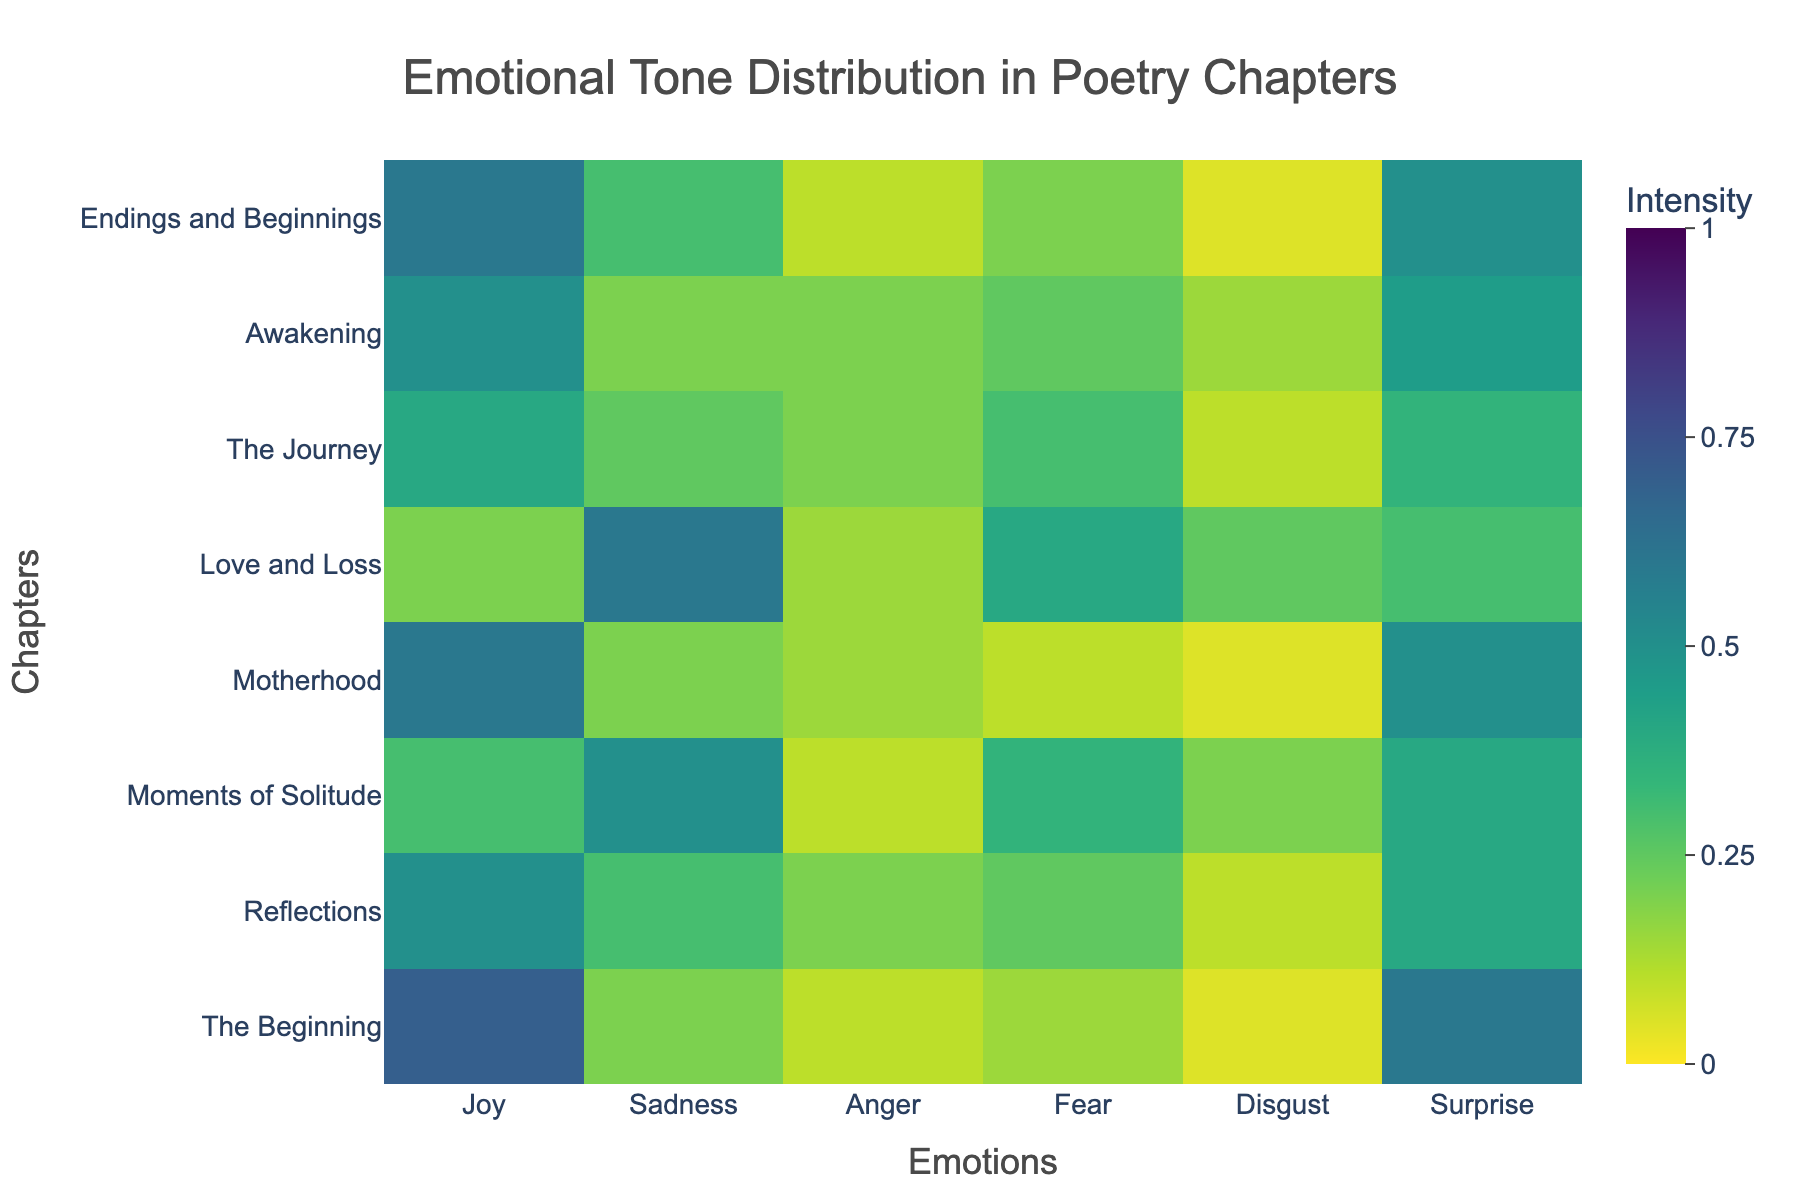What is the title of the figure? The title of a Heatmap is displayed at the top center of the figure. It provides a summary of what the graph represents. From the given information, it is "Emotional Tone Distribution in Poetry Chapters"
Answer: Emotional Tone Distribution in Poetry Chapters Which chapter has the highest intensity of joy? To answer this, look at the row corresponding to each chapter and identify the one with the highest value in the "Joy" column. "The Beginning" and "Motherhood" both show intensity 0.7, which is the highest.
Answer: The Beginning Which emotion has the highest intensity in the chapter "Love and Loss"? Check the "Love and Loss" row and find the maximum value among all emotions. In this row, the highest value is 0.6, which corresponds to "Sadness".
Answer: Sadness How does the intensity of sadness in "Reflections" compare to "Moments of Solitude"? Identify the value of sadness in both chapters by examining the "Sadness" column. "Reflections" has 0.3, and "Moments of Solitude" has 0.5. Since 0.5 > 0.3, sadness is higher in "Moments of Solitude".
Answer: Sadness is higher in Moments of Solitude Calculate the average intensity of fear across all chapters. Sum the values for "Fear" for all chapters and then divide by the number of chapters. The sum is 0.15 + 0.25 + 0.35 + 0.1 + 0.4 + 0.3 + 0.25 + 0.2 = 2.00. There are 8 chapters so the average is 2.00/8 = 0.25
Answer: 0.25 Which chapter exhibits the lowest intensity of disgust? Check the values in the "Disgust" column across all chapters and find the minimum value. The lowest intensity is 0.05, which appears in "The Beginning", "Motherhood", and "Endings and Beginnings".
Answer: The Beginning, Motherhood, Endings and Beginnings What is the most commonly high (>0.5) intensity emotion among all chapters? Identify the emotions with values greater than 0.5 across all chapters and count their occurrences. "Surprise" and "Sadness" both appear as high intensity. However, upon closer inspection, "Surprise" appears to be more frequent.
Answer: Surprise In which chapters is the intensity of anger exactly 0.2? Look at the "Anger" column and find chapters with a value of 0.2. These are "Reflections", "The Journey", and "Awakening".
Answer: Reflections, The Journey, Awakening What is the combined intensity of joy and sadness in "The Beginning"? Sum the values of joy and sadness for "The Beginning". Joy is 0.7 and sadness is 0.2, so 0.7 + 0.2 = 0.9
Answer: 0.9 How does the distribution of emotions in "Motherhood" compare to "Endings and Beginnings"? For both chapters, compare each emotion's intensity. "Motherhood" values are Joy=0.6, Sadness=0.2, Anger=0.15, Fear=0.1, Disgust=0.05, Surprise=0.5. "Endings and Beginnings" has the respective values of Joy=0.6, Sadness=0.3, Anger=0.1, Fear=0.2, Disgust=0.05, Surprise=0.5. They have similar intensities, with differences in sadness and fear.
Answer: Similar with differences in sadness and fear 